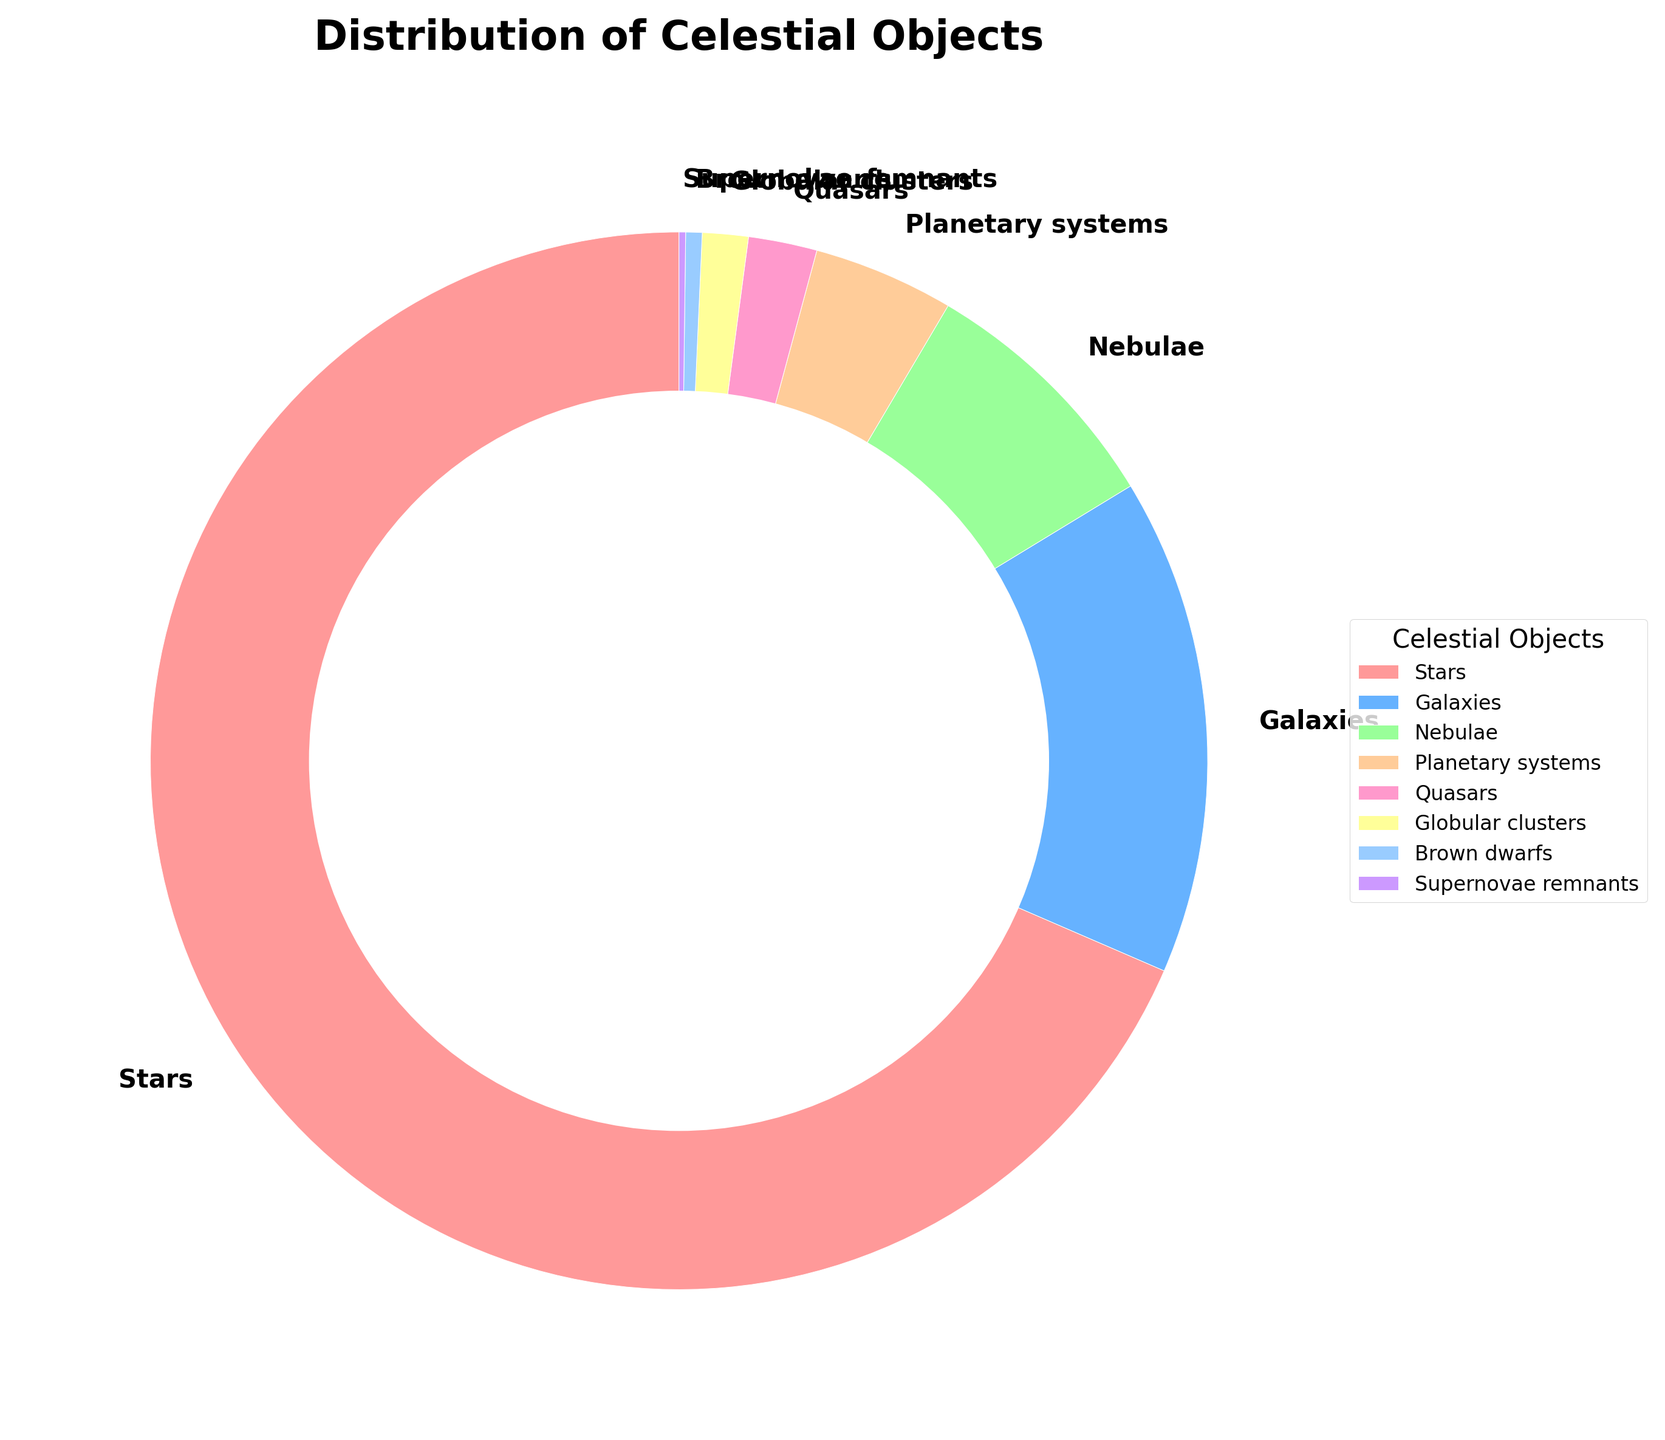Which celestial object type has the highest percentage of observation? By looking at the sizes of the wedges in the pie chart and the provided percentages, the wedge labeled "Stars" appears the largest with 68.5%.
Answer: Stars What is the combined percentage of Galaxies and Nebulae observations? The percentage of Galaxies is 15.2% and Nebulae is 7.8%. Adding these together yields: 15.2 + 7.8 = 23.0%.
Answer: 23.0% Which celestial object type has the smallest percentage of observation? The smallest wedge in the pie chart corresponds to Supernovae remnants, labeled at 0.2%.
Answer: Supernovae remnants Is the percentage of Star observations greater than the combined percentage of Planetary systems, Quasars, and Brown dwarfs? The percentage of Stars is 68.5%. The combined percentage of Planetary systems, Quasars, and Brown dwarfs is: 4.3 + 2.1 + 0.5 = 6.9%. Since 68.5% > 6.9%, the percentage of Star observations is indeed greater.
Answer: Yes Which wedge is directly to the right of the Galaxies wedge in the pie chart? Observing the pie chart, the wedge directly to the right of the Galaxies wedge, labeled 15.2%, is the Nebulae wedge, labeled 7.8%.
Answer: Nebulae How much larger is the percentage of Star observations compared to that of Galaxies? The percentage of Star observations is 68.5%, and the percentage of Galaxies is 15.2%. Subtracting these yields: 68.5 - 15.2 = 53.3%.
Answer: 53.3% Combine the percentages of Globular clusters and Brown dwarfs, then compare to the percentage of Quasars. Which is greater? Adding the percentages of Globular clusters (1.4%) and Brown dwarfs (0.5%) gives: 1.4 + 0.5 = 1.9%. The percentage of Quasars is 2.1%. Comparing them, 2.1% is greater than 1.9%.
Answer: Quasars What is the total percentage of observations for all celestial objects that are not Stars? Subtracting the percentage of Stars (68.5%) from 100% gives: 100 - 68.5 = 31.5%.
Answer: 31.5% How does the color of the wedge representing Brown dwarfs compare to the color of the wedge representing Supernovae remnants? Observing the colors in the pie chart, the Brown dwarfs wedge is light blue while the Supernovae remnants wedge is purple.
Answer: Light blue and purple If a new category was added with a 5% observation percentage, how would it compare to the percentage of Planetary systems? The percentage of Planetary systems is 4.3%. A new category with a 5% observation percentage is slightly higher than 4.3%.
Answer: Higher than Planetary systems 